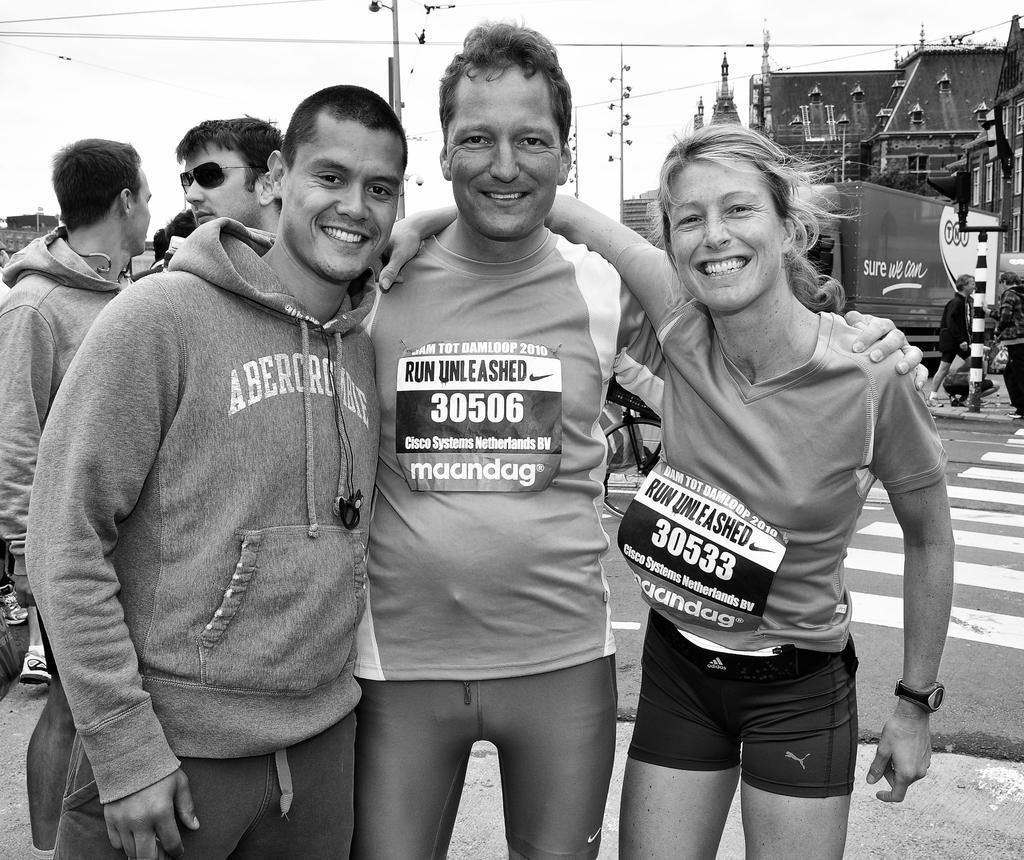What is the color scheme of the image? The image is black and white. What can be seen in the foreground of the image? There are groups of people standing in the image. What is located behind the people in the image? There is a vehicle behind the people. What objects are present in the image that are related to infrastructure? There are poles and cables in the image. What can be seen in the background of the image? There are buildings and the sky visible in the background of the image. How does the paste help the people in the image? There is no paste present in the image. 